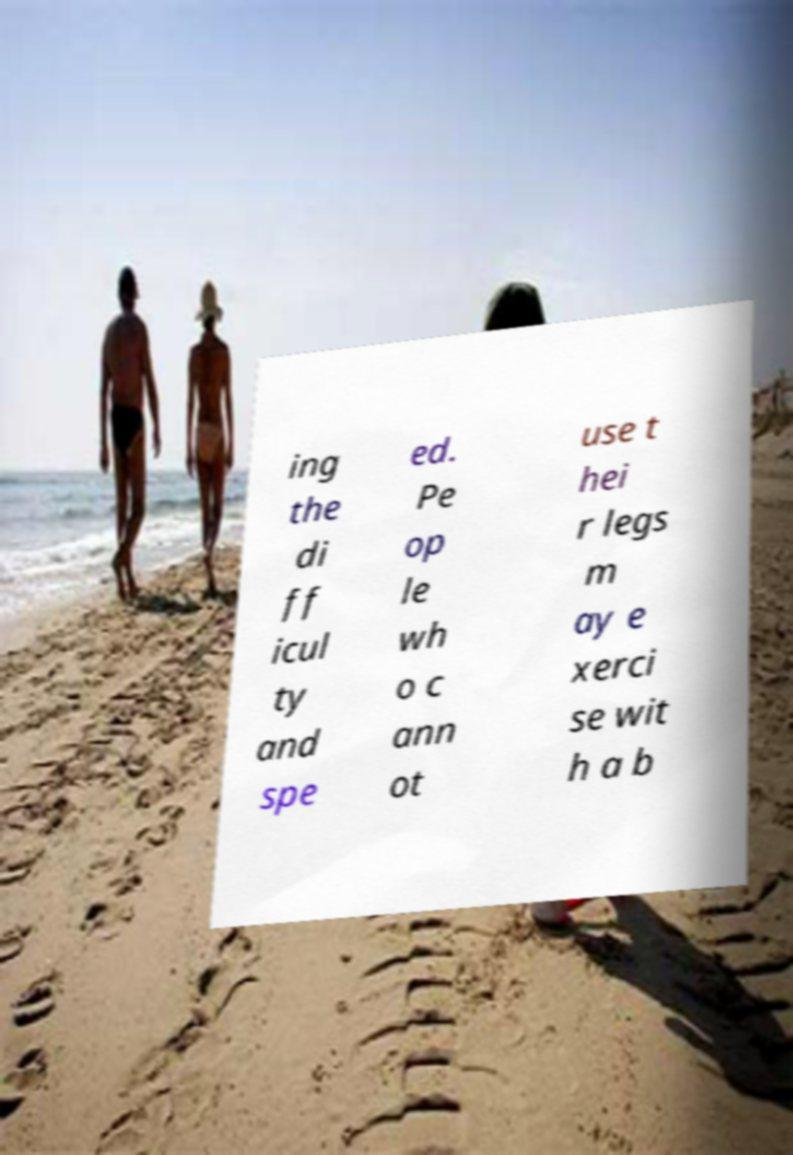Please identify and transcribe the text found in this image. ing the di ff icul ty and spe ed. Pe op le wh o c ann ot use t hei r legs m ay e xerci se wit h a b 